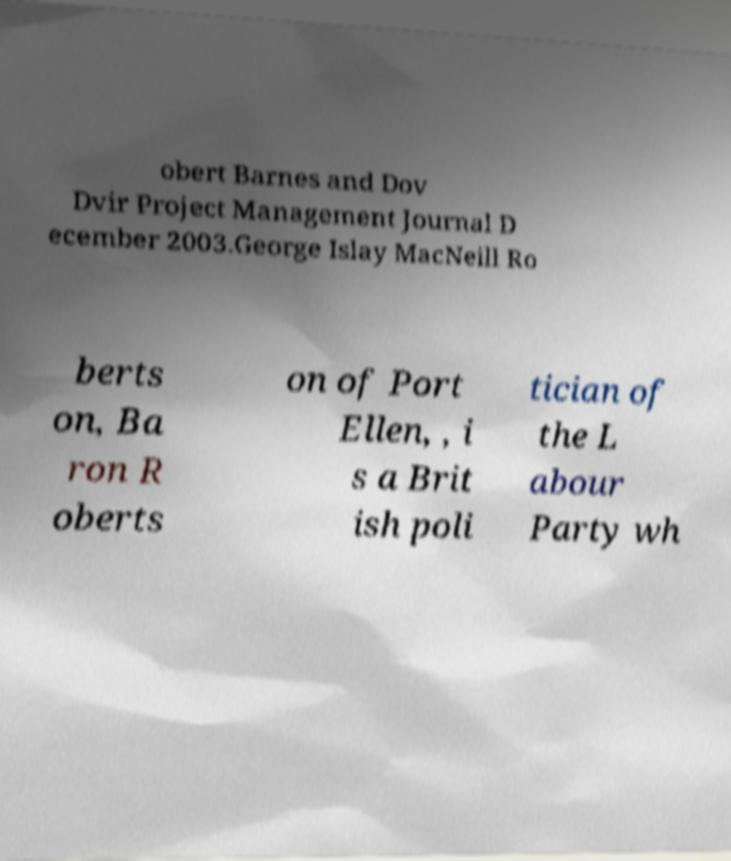Please identify and transcribe the text found in this image. obert Barnes and Dov Dvir Project Management Journal D ecember 2003.George Islay MacNeill Ro berts on, Ba ron R oberts on of Port Ellen, , i s a Brit ish poli tician of the L abour Party wh 